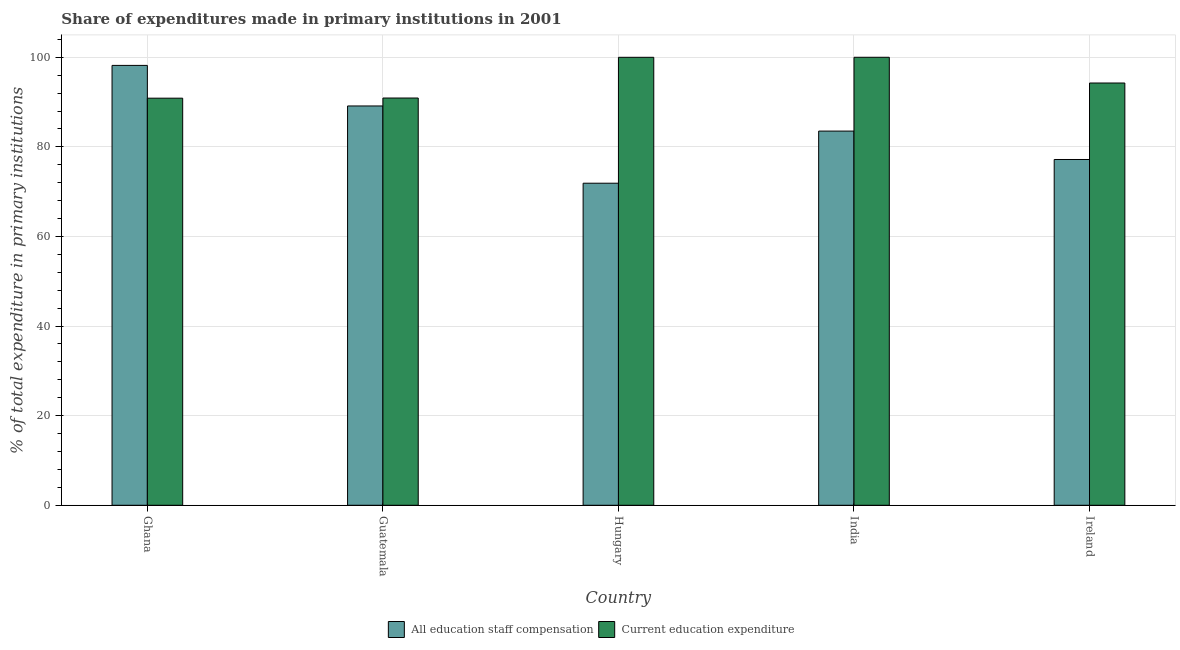How many different coloured bars are there?
Your answer should be very brief. 2. How many groups of bars are there?
Your response must be concise. 5. Are the number of bars per tick equal to the number of legend labels?
Your response must be concise. Yes. What is the label of the 2nd group of bars from the left?
Keep it short and to the point. Guatemala. What is the expenditure in staff compensation in India?
Provide a succinct answer. 83.52. Across all countries, what is the maximum expenditure in staff compensation?
Provide a short and direct response. 98.19. Across all countries, what is the minimum expenditure in staff compensation?
Ensure brevity in your answer.  71.89. In which country was the expenditure in staff compensation maximum?
Ensure brevity in your answer.  Ghana. What is the total expenditure in staff compensation in the graph?
Keep it short and to the point. 419.92. What is the difference between the expenditure in staff compensation in Ghana and that in Guatemala?
Your answer should be very brief. 9.06. What is the difference between the expenditure in education in Ghana and the expenditure in staff compensation in Hungary?
Your answer should be compact. 18.98. What is the average expenditure in education per country?
Offer a very short reply. 95.2. What is the difference between the expenditure in staff compensation and expenditure in education in Hungary?
Keep it short and to the point. -28.1. What is the ratio of the expenditure in education in Guatemala to that in India?
Your answer should be compact. 0.91. Is the expenditure in education in Hungary less than that in Ireland?
Ensure brevity in your answer.  No. What is the difference between the highest and the second highest expenditure in education?
Provide a succinct answer. 0.01. What is the difference between the highest and the lowest expenditure in staff compensation?
Provide a succinct answer. 26.3. What does the 2nd bar from the left in Guatemala represents?
Offer a very short reply. Current education expenditure. What does the 2nd bar from the right in India represents?
Provide a succinct answer. All education staff compensation. What is the difference between two consecutive major ticks on the Y-axis?
Offer a very short reply. 20. Are the values on the major ticks of Y-axis written in scientific E-notation?
Provide a short and direct response. No. Does the graph contain any zero values?
Keep it short and to the point. No. Does the graph contain grids?
Give a very brief answer. Yes. Where does the legend appear in the graph?
Give a very brief answer. Bottom center. How many legend labels are there?
Provide a short and direct response. 2. What is the title of the graph?
Give a very brief answer. Share of expenditures made in primary institutions in 2001. Does "Female" appear as one of the legend labels in the graph?
Your answer should be very brief. No. What is the label or title of the Y-axis?
Your response must be concise. % of total expenditure in primary institutions. What is the % of total expenditure in primary institutions of All education staff compensation in Ghana?
Make the answer very short. 98.19. What is the % of total expenditure in primary institutions in Current education expenditure in Ghana?
Offer a very short reply. 90.87. What is the % of total expenditure in primary institutions of All education staff compensation in Guatemala?
Make the answer very short. 89.13. What is the % of total expenditure in primary institutions of Current education expenditure in Guatemala?
Ensure brevity in your answer.  90.9. What is the % of total expenditure in primary institutions of All education staff compensation in Hungary?
Offer a terse response. 71.89. What is the % of total expenditure in primary institutions in Current education expenditure in Hungary?
Keep it short and to the point. 99.99. What is the % of total expenditure in primary institutions of All education staff compensation in India?
Make the answer very short. 83.52. What is the % of total expenditure in primary institutions in Current education expenditure in India?
Your answer should be very brief. 100. What is the % of total expenditure in primary institutions of All education staff compensation in Ireland?
Your answer should be compact. 77.18. What is the % of total expenditure in primary institutions of Current education expenditure in Ireland?
Offer a terse response. 94.26. Across all countries, what is the maximum % of total expenditure in primary institutions in All education staff compensation?
Keep it short and to the point. 98.19. Across all countries, what is the maximum % of total expenditure in primary institutions of Current education expenditure?
Provide a succinct answer. 100. Across all countries, what is the minimum % of total expenditure in primary institutions of All education staff compensation?
Give a very brief answer. 71.89. Across all countries, what is the minimum % of total expenditure in primary institutions in Current education expenditure?
Your answer should be compact. 90.87. What is the total % of total expenditure in primary institutions of All education staff compensation in the graph?
Give a very brief answer. 419.92. What is the total % of total expenditure in primary institutions of Current education expenditure in the graph?
Your answer should be compact. 476.02. What is the difference between the % of total expenditure in primary institutions in All education staff compensation in Ghana and that in Guatemala?
Offer a very short reply. 9.06. What is the difference between the % of total expenditure in primary institutions of Current education expenditure in Ghana and that in Guatemala?
Ensure brevity in your answer.  -0.04. What is the difference between the % of total expenditure in primary institutions of All education staff compensation in Ghana and that in Hungary?
Give a very brief answer. 26.3. What is the difference between the % of total expenditure in primary institutions of Current education expenditure in Ghana and that in Hungary?
Keep it short and to the point. -9.13. What is the difference between the % of total expenditure in primary institutions of All education staff compensation in Ghana and that in India?
Give a very brief answer. 14.66. What is the difference between the % of total expenditure in primary institutions of Current education expenditure in Ghana and that in India?
Give a very brief answer. -9.13. What is the difference between the % of total expenditure in primary institutions of All education staff compensation in Ghana and that in Ireland?
Make the answer very short. 21. What is the difference between the % of total expenditure in primary institutions in Current education expenditure in Ghana and that in Ireland?
Give a very brief answer. -3.39. What is the difference between the % of total expenditure in primary institutions in All education staff compensation in Guatemala and that in Hungary?
Keep it short and to the point. 17.24. What is the difference between the % of total expenditure in primary institutions in Current education expenditure in Guatemala and that in Hungary?
Your answer should be very brief. -9.09. What is the difference between the % of total expenditure in primary institutions in All education staff compensation in Guatemala and that in India?
Offer a terse response. 5.61. What is the difference between the % of total expenditure in primary institutions in Current education expenditure in Guatemala and that in India?
Your response must be concise. -9.1. What is the difference between the % of total expenditure in primary institutions in All education staff compensation in Guatemala and that in Ireland?
Keep it short and to the point. 11.95. What is the difference between the % of total expenditure in primary institutions in Current education expenditure in Guatemala and that in Ireland?
Give a very brief answer. -3.35. What is the difference between the % of total expenditure in primary institutions in All education staff compensation in Hungary and that in India?
Offer a terse response. -11.63. What is the difference between the % of total expenditure in primary institutions of Current education expenditure in Hungary and that in India?
Give a very brief answer. -0.01. What is the difference between the % of total expenditure in primary institutions in All education staff compensation in Hungary and that in Ireland?
Offer a very short reply. -5.29. What is the difference between the % of total expenditure in primary institutions in Current education expenditure in Hungary and that in Ireland?
Your response must be concise. 5.74. What is the difference between the % of total expenditure in primary institutions of All education staff compensation in India and that in Ireland?
Offer a very short reply. 6.34. What is the difference between the % of total expenditure in primary institutions in Current education expenditure in India and that in Ireland?
Offer a terse response. 5.74. What is the difference between the % of total expenditure in primary institutions in All education staff compensation in Ghana and the % of total expenditure in primary institutions in Current education expenditure in Guatemala?
Offer a very short reply. 7.28. What is the difference between the % of total expenditure in primary institutions of All education staff compensation in Ghana and the % of total expenditure in primary institutions of Current education expenditure in Hungary?
Offer a terse response. -1.81. What is the difference between the % of total expenditure in primary institutions in All education staff compensation in Ghana and the % of total expenditure in primary institutions in Current education expenditure in India?
Keep it short and to the point. -1.81. What is the difference between the % of total expenditure in primary institutions in All education staff compensation in Ghana and the % of total expenditure in primary institutions in Current education expenditure in Ireland?
Ensure brevity in your answer.  3.93. What is the difference between the % of total expenditure in primary institutions of All education staff compensation in Guatemala and the % of total expenditure in primary institutions of Current education expenditure in Hungary?
Your answer should be very brief. -10.86. What is the difference between the % of total expenditure in primary institutions of All education staff compensation in Guatemala and the % of total expenditure in primary institutions of Current education expenditure in India?
Your answer should be very brief. -10.87. What is the difference between the % of total expenditure in primary institutions of All education staff compensation in Guatemala and the % of total expenditure in primary institutions of Current education expenditure in Ireland?
Your answer should be very brief. -5.12. What is the difference between the % of total expenditure in primary institutions of All education staff compensation in Hungary and the % of total expenditure in primary institutions of Current education expenditure in India?
Ensure brevity in your answer.  -28.11. What is the difference between the % of total expenditure in primary institutions in All education staff compensation in Hungary and the % of total expenditure in primary institutions in Current education expenditure in Ireland?
Your answer should be very brief. -22.37. What is the difference between the % of total expenditure in primary institutions in All education staff compensation in India and the % of total expenditure in primary institutions in Current education expenditure in Ireland?
Ensure brevity in your answer.  -10.73. What is the average % of total expenditure in primary institutions in All education staff compensation per country?
Give a very brief answer. 83.98. What is the average % of total expenditure in primary institutions in Current education expenditure per country?
Your answer should be compact. 95.2. What is the difference between the % of total expenditure in primary institutions of All education staff compensation and % of total expenditure in primary institutions of Current education expenditure in Ghana?
Your answer should be compact. 7.32. What is the difference between the % of total expenditure in primary institutions in All education staff compensation and % of total expenditure in primary institutions in Current education expenditure in Guatemala?
Offer a terse response. -1.77. What is the difference between the % of total expenditure in primary institutions of All education staff compensation and % of total expenditure in primary institutions of Current education expenditure in Hungary?
Your answer should be very brief. -28.1. What is the difference between the % of total expenditure in primary institutions of All education staff compensation and % of total expenditure in primary institutions of Current education expenditure in India?
Give a very brief answer. -16.48. What is the difference between the % of total expenditure in primary institutions of All education staff compensation and % of total expenditure in primary institutions of Current education expenditure in Ireland?
Offer a very short reply. -17.07. What is the ratio of the % of total expenditure in primary institutions in All education staff compensation in Ghana to that in Guatemala?
Your answer should be very brief. 1.1. What is the ratio of the % of total expenditure in primary institutions of Current education expenditure in Ghana to that in Guatemala?
Provide a succinct answer. 1. What is the ratio of the % of total expenditure in primary institutions in All education staff compensation in Ghana to that in Hungary?
Provide a succinct answer. 1.37. What is the ratio of the % of total expenditure in primary institutions of Current education expenditure in Ghana to that in Hungary?
Give a very brief answer. 0.91. What is the ratio of the % of total expenditure in primary institutions of All education staff compensation in Ghana to that in India?
Your response must be concise. 1.18. What is the ratio of the % of total expenditure in primary institutions of Current education expenditure in Ghana to that in India?
Offer a very short reply. 0.91. What is the ratio of the % of total expenditure in primary institutions in All education staff compensation in Ghana to that in Ireland?
Provide a succinct answer. 1.27. What is the ratio of the % of total expenditure in primary institutions in Current education expenditure in Ghana to that in Ireland?
Give a very brief answer. 0.96. What is the ratio of the % of total expenditure in primary institutions in All education staff compensation in Guatemala to that in Hungary?
Offer a terse response. 1.24. What is the ratio of the % of total expenditure in primary institutions of All education staff compensation in Guatemala to that in India?
Offer a very short reply. 1.07. What is the ratio of the % of total expenditure in primary institutions of Current education expenditure in Guatemala to that in India?
Your answer should be compact. 0.91. What is the ratio of the % of total expenditure in primary institutions of All education staff compensation in Guatemala to that in Ireland?
Keep it short and to the point. 1.15. What is the ratio of the % of total expenditure in primary institutions in Current education expenditure in Guatemala to that in Ireland?
Provide a short and direct response. 0.96. What is the ratio of the % of total expenditure in primary institutions of All education staff compensation in Hungary to that in India?
Ensure brevity in your answer.  0.86. What is the ratio of the % of total expenditure in primary institutions of All education staff compensation in Hungary to that in Ireland?
Give a very brief answer. 0.93. What is the ratio of the % of total expenditure in primary institutions of Current education expenditure in Hungary to that in Ireland?
Your response must be concise. 1.06. What is the ratio of the % of total expenditure in primary institutions of All education staff compensation in India to that in Ireland?
Give a very brief answer. 1.08. What is the ratio of the % of total expenditure in primary institutions in Current education expenditure in India to that in Ireland?
Ensure brevity in your answer.  1.06. What is the difference between the highest and the second highest % of total expenditure in primary institutions in All education staff compensation?
Keep it short and to the point. 9.06. What is the difference between the highest and the second highest % of total expenditure in primary institutions in Current education expenditure?
Provide a succinct answer. 0.01. What is the difference between the highest and the lowest % of total expenditure in primary institutions in All education staff compensation?
Offer a very short reply. 26.3. What is the difference between the highest and the lowest % of total expenditure in primary institutions of Current education expenditure?
Give a very brief answer. 9.13. 